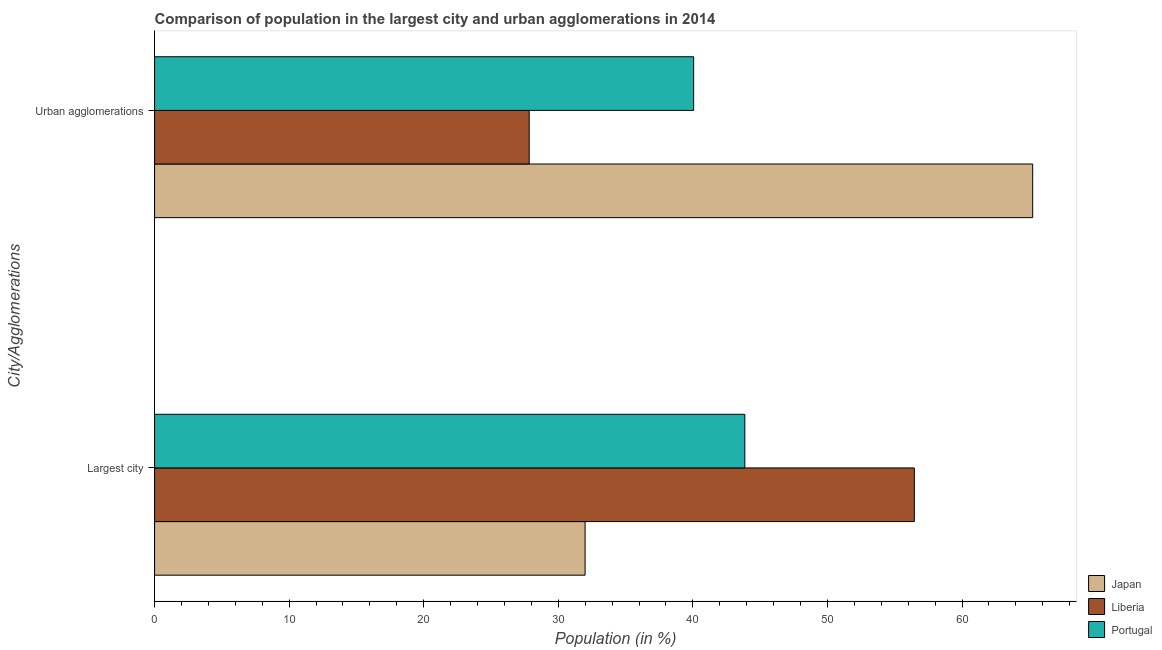How many groups of bars are there?
Your response must be concise. 2. How many bars are there on the 1st tick from the bottom?
Provide a short and direct response. 3. What is the label of the 1st group of bars from the top?
Your answer should be very brief. Urban agglomerations. What is the population in urban agglomerations in Portugal?
Ensure brevity in your answer.  40.06. Across all countries, what is the maximum population in the largest city?
Offer a very short reply. 56.46. Across all countries, what is the minimum population in urban agglomerations?
Your answer should be compact. 27.84. In which country was the population in the largest city maximum?
Offer a terse response. Liberia. In which country was the population in the largest city minimum?
Keep it short and to the point. Japan. What is the total population in urban agglomerations in the graph?
Provide a short and direct response. 133.15. What is the difference between the population in urban agglomerations in Liberia and that in Japan?
Your answer should be very brief. -37.41. What is the difference between the population in urban agglomerations in Japan and the population in the largest city in Portugal?
Your answer should be compact. 21.39. What is the average population in the largest city per country?
Provide a succinct answer. 44.1. What is the difference between the population in the largest city and population in urban agglomerations in Japan?
Give a very brief answer. -33.26. In how many countries, is the population in urban agglomerations greater than 4 %?
Your answer should be very brief. 3. What is the ratio of the population in urban agglomerations in Japan to that in Liberia?
Your answer should be very brief. 2.34. Is the population in urban agglomerations in Portugal less than that in Japan?
Ensure brevity in your answer.  Yes. What does the 2nd bar from the bottom in Urban agglomerations represents?
Ensure brevity in your answer.  Liberia. How many countries are there in the graph?
Offer a very short reply. 3. Does the graph contain any zero values?
Provide a short and direct response. No. Does the graph contain grids?
Make the answer very short. No. Where does the legend appear in the graph?
Give a very brief answer. Bottom right. What is the title of the graph?
Give a very brief answer. Comparison of population in the largest city and urban agglomerations in 2014. Does "Malta" appear as one of the legend labels in the graph?
Ensure brevity in your answer.  No. What is the label or title of the Y-axis?
Make the answer very short. City/Agglomerations. What is the Population (in %) in Japan in Largest city?
Offer a very short reply. 31.99. What is the Population (in %) of Liberia in Largest city?
Your response must be concise. 56.46. What is the Population (in %) of Portugal in Largest city?
Provide a short and direct response. 43.86. What is the Population (in %) of Japan in Urban agglomerations?
Your response must be concise. 65.25. What is the Population (in %) in Liberia in Urban agglomerations?
Provide a short and direct response. 27.84. What is the Population (in %) in Portugal in Urban agglomerations?
Provide a short and direct response. 40.06. Across all City/Agglomerations, what is the maximum Population (in %) in Japan?
Make the answer very short. 65.25. Across all City/Agglomerations, what is the maximum Population (in %) of Liberia?
Keep it short and to the point. 56.46. Across all City/Agglomerations, what is the maximum Population (in %) of Portugal?
Keep it short and to the point. 43.86. Across all City/Agglomerations, what is the minimum Population (in %) in Japan?
Your answer should be compact. 31.99. Across all City/Agglomerations, what is the minimum Population (in %) of Liberia?
Offer a very short reply. 27.84. Across all City/Agglomerations, what is the minimum Population (in %) in Portugal?
Your answer should be very brief. 40.06. What is the total Population (in %) in Japan in the graph?
Provide a short and direct response. 97.24. What is the total Population (in %) of Liberia in the graph?
Your answer should be very brief. 84.29. What is the total Population (in %) of Portugal in the graph?
Offer a terse response. 83.92. What is the difference between the Population (in %) of Japan in Largest city and that in Urban agglomerations?
Ensure brevity in your answer.  -33.26. What is the difference between the Population (in %) in Liberia in Largest city and that in Urban agglomerations?
Make the answer very short. 28.62. What is the difference between the Population (in %) of Portugal in Largest city and that in Urban agglomerations?
Provide a succinct answer. 3.8. What is the difference between the Population (in %) in Japan in Largest city and the Population (in %) in Liberia in Urban agglomerations?
Your response must be concise. 4.15. What is the difference between the Population (in %) of Japan in Largest city and the Population (in %) of Portugal in Urban agglomerations?
Keep it short and to the point. -8.07. What is the difference between the Population (in %) in Liberia in Largest city and the Population (in %) in Portugal in Urban agglomerations?
Your answer should be very brief. 16.4. What is the average Population (in %) in Japan per City/Agglomerations?
Give a very brief answer. 48.62. What is the average Population (in %) of Liberia per City/Agglomerations?
Your response must be concise. 42.15. What is the average Population (in %) of Portugal per City/Agglomerations?
Ensure brevity in your answer.  41.96. What is the difference between the Population (in %) of Japan and Population (in %) of Liberia in Largest city?
Keep it short and to the point. -24.46. What is the difference between the Population (in %) in Japan and Population (in %) in Portugal in Largest city?
Offer a very short reply. -11.87. What is the difference between the Population (in %) in Liberia and Population (in %) in Portugal in Largest city?
Keep it short and to the point. 12.59. What is the difference between the Population (in %) of Japan and Population (in %) of Liberia in Urban agglomerations?
Offer a very short reply. 37.41. What is the difference between the Population (in %) of Japan and Population (in %) of Portugal in Urban agglomerations?
Offer a very short reply. 25.19. What is the difference between the Population (in %) in Liberia and Population (in %) in Portugal in Urban agglomerations?
Provide a succinct answer. -12.22. What is the ratio of the Population (in %) in Japan in Largest city to that in Urban agglomerations?
Ensure brevity in your answer.  0.49. What is the ratio of the Population (in %) of Liberia in Largest city to that in Urban agglomerations?
Your answer should be compact. 2.03. What is the ratio of the Population (in %) in Portugal in Largest city to that in Urban agglomerations?
Provide a short and direct response. 1.09. What is the difference between the highest and the second highest Population (in %) of Japan?
Offer a very short reply. 33.26. What is the difference between the highest and the second highest Population (in %) of Liberia?
Offer a terse response. 28.62. What is the difference between the highest and the second highest Population (in %) in Portugal?
Your answer should be very brief. 3.8. What is the difference between the highest and the lowest Population (in %) in Japan?
Your answer should be very brief. 33.26. What is the difference between the highest and the lowest Population (in %) in Liberia?
Ensure brevity in your answer.  28.62. What is the difference between the highest and the lowest Population (in %) in Portugal?
Offer a terse response. 3.8. 